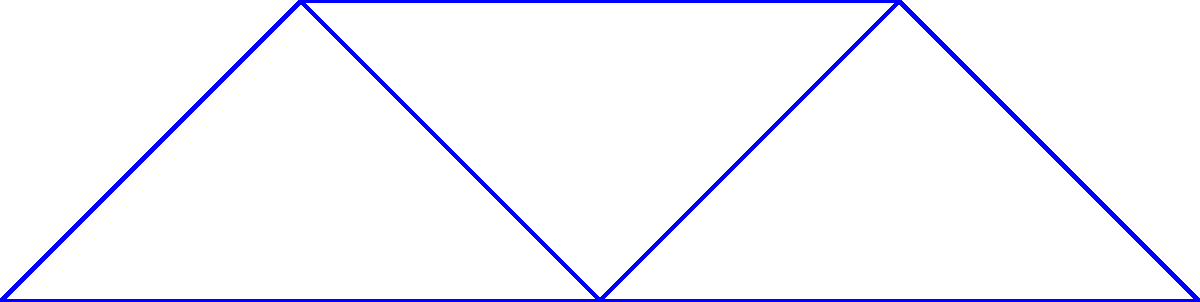Given the network topology represented by the graph above, where vertices represent network nodes and edge weights represent the cost of establishing connections, determine the minimum spanning tree (MST) that optimizes the network connectivity. What is the total cost of the MST? To find the minimum spanning tree (MST) and its total cost, we'll use Kruskal's algorithm:

1. Sort all edges by weight in ascending order:
   $(v_2, v_3): 1$
   $(v_4, v_5): 1$
   $(v_1, v_2): 2$
   $(v_3, v_4): 2$
   $(v_1, v_3): 3$
   $(v_3, v_5): 3$
   $(v_2, v_4): 4$

2. Start with an empty MST and add edges in order, avoiding cycles:
   - Add $(v_2, v_3): 1$
   - Add $(v_4, v_5): 1$
   - Add $(v_1, v_2): 2$
   - Add $(v_3, v_4): 2$

3. The MST is complete as it now includes all vertices.

4. Calculate the total cost:
   $1 + 1 + 2 + 2 = 6$

Therefore, the minimum spanning tree has a total cost of 6.
Answer: 6 